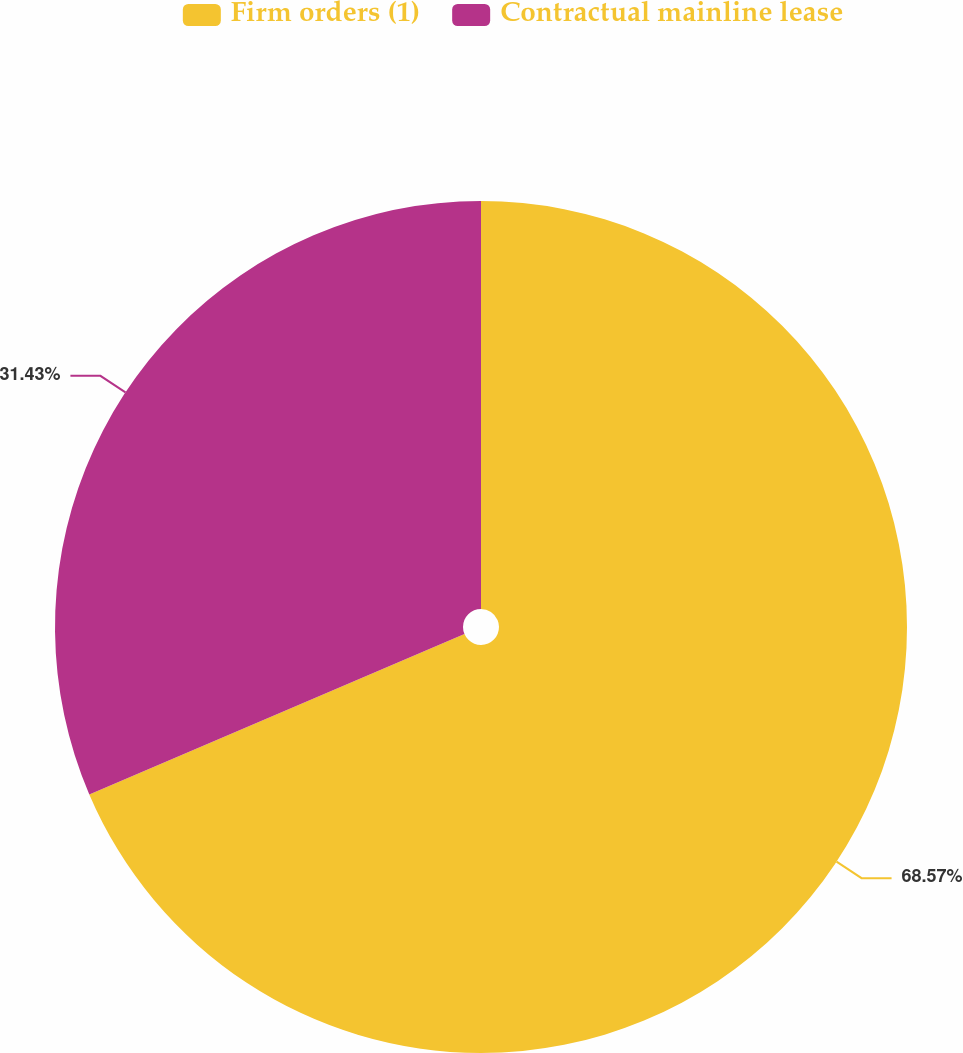Convert chart to OTSL. <chart><loc_0><loc_0><loc_500><loc_500><pie_chart><fcel>Firm orders (1)<fcel>Contractual mainline lease<nl><fcel>68.57%<fcel>31.43%<nl></chart> 